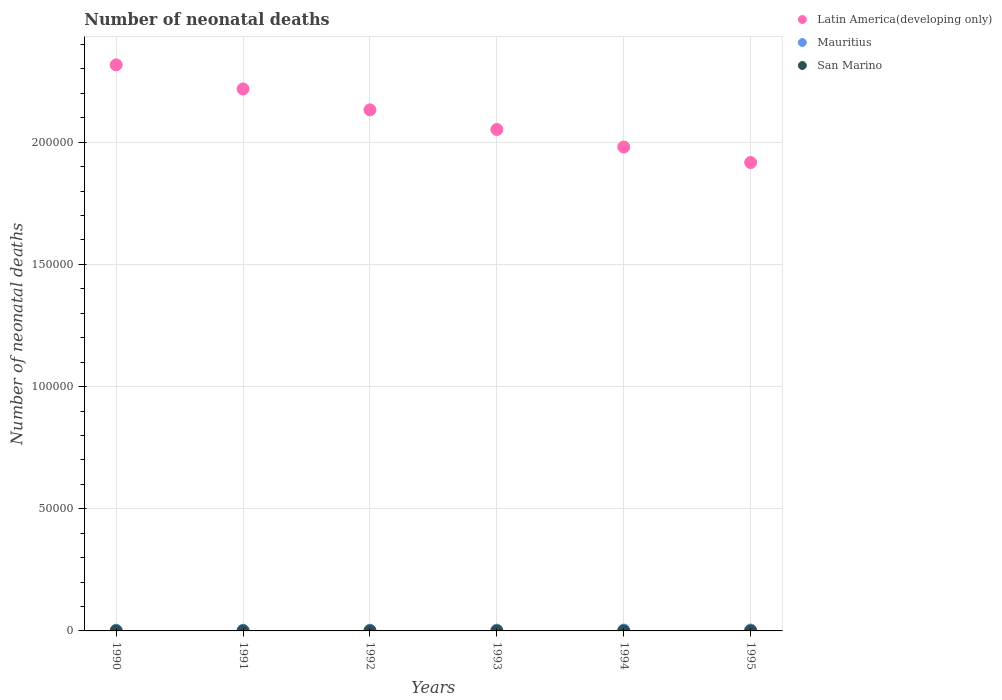How many different coloured dotlines are there?
Your answer should be compact. 3. Is the number of dotlines equal to the number of legend labels?
Keep it short and to the point. Yes. What is the number of neonatal deaths in in Mauritius in 1990?
Offer a terse response. 285. Across all years, what is the maximum number of neonatal deaths in in San Marino?
Your answer should be compact. 2. Across all years, what is the minimum number of neonatal deaths in in Latin America(developing only)?
Provide a succinct answer. 1.92e+05. In which year was the number of neonatal deaths in in Mauritius minimum?
Make the answer very short. 1990. What is the total number of neonatal deaths in in Latin America(developing only) in the graph?
Your answer should be very brief. 1.26e+06. What is the difference between the number of neonatal deaths in in Mauritius in 1990 and that in 1992?
Ensure brevity in your answer.  -22. What is the difference between the number of neonatal deaths in in Mauritius in 1991 and the number of neonatal deaths in in San Marino in 1990?
Your answer should be very brief. 287. What is the average number of neonatal deaths in in Latin America(developing only) per year?
Make the answer very short. 2.10e+05. In the year 1990, what is the difference between the number of neonatal deaths in in Mauritius and number of neonatal deaths in in Latin America(developing only)?
Offer a terse response. -2.31e+05. Is the difference between the number of neonatal deaths in in Mauritius in 1992 and 1993 greater than the difference between the number of neonatal deaths in in Latin America(developing only) in 1992 and 1993?
Your answer should be compact. No. What is the difference between the highest and the second highest number of neonatal deaths in in Latin America(developing only)?
Ensure brevity in your answer.  9854. What is the difference between the highest and the lowest number of neonatal deaths in in Latin America(developing only)?
Provide a short and direct response. 4.00e+04. In how many years, is the number of neonatal deaths in in Mauritius greater than the average number of neonatal deaths in in Mauritius taken over all years?
Provide a succinct answer. 3. Is the sum of the number of neonatal deaths in in San Marino in 1992 and 1993 greater than the maximum number of neonatal deaths in in Latin America(developing only) across all years?
Ensure brevity in your answer.  No. Is it the case that in every year, the sum of the number of neonatal deaths in in Mauritius and number of neonatal deaths in in Latin America(developing only)  is greater than the number of neonatal deaths in in San Marino?
Provide a succinct answer. Yes. Does the number of neonatal deaths in in Latin America(developing only) monotonically increase over the years?
Ensure brevity in your answer.  No. Is the number of neonatal deaths in in Latin America(developing only) strictly greater than the number of neonatal deaths in in Mauritius over the years?
Your response must be concise. Yes. Is the number of neonatal deaths in in Mauritius strictly less than the number of neonatal deaths in in Latin America(developing only) over the years?
Provide a succinct answer. Yes. Are the values on the major ticks of Y-axis written in scientific E-notation?
Provide a succinct answer. No. Does the graph contain grids?
Your answer should be very brief. Yes. Where does the legend appear in the graph?
Provide a succinct answer. Top right. How are the legend labels stacked?
Give a very brief answer. Vertical. What is the title of the graph?
Your answer should be compact. Number of neonatal deaths. What is the label or title of the Y-axis?
Your answer should be compact. Number of neonatal deaths. What is the Number of neonatal deaths in Latin America(developing only) in 1990?
Your answer should be compact. 2.32e+05. What is the Number of neonatal deaths in Mauritius in 1990?
Provide a succinct answer. 285. What is the Number of neonatal deaths in San Marino in 1990?
Your answer should be very brief. 2. What is the Number of neonatal deaths in Latin America(developing only) in 1991?
Your answer should be compact. 2.22e+05. What is the Number of neonatal deaths in Mauritius in 1991?
Give a very brief answer. 289. What is the Number of neonatal deaths of Latin America(developing only) in 1992?
Offer a terse response. 2.13e+05. What is the Number of neonatal deaths in Mauritius in 1992?
Provide a succinct answer. 307. What is the Number of neonatal deaths of Latin America(developing only) in 1993?
Give a very brief answer. 2.05e+05. What is the Number of neonatal deaths in Mauritius in 1993?
Give a very brief answer. 333. What is the Number of neonatal deaths of San Marino in 1993?
Give a very brief answer. 1. What is the Number of neonatal deaths of Latin America(developing only) in 1994?
Keep it short and to the point. 1.98e+05. What is the Number of neonatal deaths of Mauritius in 1994?
Make the answer very short. 359. What is the Number of neonatal deaths of Latin America(developing only) in 1995?
Provide a succinct answer. 1.92e+05. What is the Number of neonatal deaths in Mauritius in 1995?
Provide a succinct answer. 378. What is the Number of neonatal deaths in San Marino in 1995?
Provide a short and direct response. 1. Across all years, what is the maximum Number of neonatal deaths in Latin America(developing only)?
Give a very brief answer. 2.32e+05. Across all years, what is the maximum Number of neonatal deaths of Mauritius?
Keep it short and to the point. 378. Across all years, what is the maximum Number of neonatal deaths in San Marino?
Offer a very short reply. 2. Across all years, what is the minimum Number of neonatal deaths of Latin America(developing only)?
Offer a terse response. 1.92e+05. Across all years, what is the minimum Number of neonatal deaths in Mauritius?
Provide a short and direct response. 285. What is the total Number of neonatal deaths of Latin America(developing only) in the graph?
Provide a short and direct response. 1.26e+06. What is the total Number of neonatal deaths in Mauritius in the graph?
Ensure brevity in your answer.  1951. What is the difference between the Number of neonatal deaths of Latin America(developing only) in 1990 and that in 1991?
Your answer should be compact. 9854. What is the difference between the Number of neonatal deaths of San Marino in 1990 and that in 1991?
Offer a very short reply. 0. What is the difference between the Number of neonatal deaths of Latin America(developing only) in 1990 and that in 1992?
Ensure brevity in your answer.  1.84e+04. What is the difference between the Number of neonatal deaths in Latin America(developing only) in 1990 and that in 1993?
Make the answer very short. 2.64e+04. What is the difference between the Number of neonatal deaths of Mauritius in 1990 and that in 1993?
Your answer should be compact. -48. What is the difference between the Number of neonatal deaths of Latin America(developing only) in 1990 and that in 1994?
Offer a very short reply. 3.36e+04. What is the difference between the Number of neonatal deaths of Mauritius in 1990 and that in 1994?
Make the answer very short. -74. What is the difference between the Number of neonatal deaths in San Marino in 1990 and that in 1994?
Provide a succinct answer. 1. What is the difference between the Number of neonatal deaths in Latin America(developing only) in 1990 and that in 1995?
Your answer should be compact. 4.00e+04. What is the difference between the Number of neonatal deaths in Mauritius in 1990 and that in 1995?
Offer a terse response. -93. What is the difference between the Number of neonatal deaths of San Marino in 1990 and that in 1995?
Ensure brevity in your answer.  1. What is the difference between the Number of neonatal deaths in Latin America(developing only) in 1991 and that in 1992?
Make the answer very short. 8559. What is the difference between the Number of neonatal deaths of San Marino in 1991 and that in 1992?
Your response must be concise. 0. What is the difference between the Number of neonatal deaths of Latin America(developing only) in 1991 and that in 1993?
Your response must be concise. 1.66e+04. What is the difference between the Number of neonatal deaths in Mauritius in 1991 and that in 1993?
Offer a very short reply. -44. What is the difference between the Number of neonatal deaths in Latin America(developing only) in 1991 and that in 1994?
Your response must be concise. 2.38e+04. What is the difference between the Number of neonatal deaths in Mauritius in 1991 and that in 1994?
Make the answer very short. -70. What is the difference between the Number of neonatal deaths of Latin America(developing only) in 1991 and that in 1995?
Your answer should be very brief. 3.01e+04. What is the difference between the Number of neonatal deaths in Mauritius in 1991 and that in 1995?
Your response must be concise. -89. What is the difference between the Number of neonatal deaths in San Marino in 1991 and that in 1995?
Your answer should be compact. 1. What is the difference between the Number of neonatal deaths of Latin America(developing only) in 1992 and that in 1993?
Your answer should be compact. 8032. What is the difference between the Number of neonatal deaths in Latin America(developing only) in 1992 and that in 1994?
Offer a very short reply. 1.52e+04. What is the difference between the Number of neonatal deaths in Mauritius in 1992 and that in 1994?
Keep it short and to the point. -52. What is the difference between the Number of neonatal deaths of Latin America(developing only) in 1992 and that in 1995?
Your response must be concise. 2.16e+04. What is the difference between the Number of neonatal deaths in Mauritius in 1992 and that in 1995?
Provide a short and direct response. -71. What is the difference between the Number of neonatal deaths of Latin America(developing only) in 1993 and that in 1994?
Offer a very short reply. 7178. What is the difference between the Number of neonatal deaths of Latin America(developing only) in 1993 and that in 1995?
Provide a short and direct response. 1.35e+04. What is the difference between the Number of neonatal deaths of Mauritius in 1993 and that in 1995?
Your answer should be very brief. -45. What is the difference between the Number of neonatal deaths in San Marino in 1993 and that in 1995?
Give a very brief answer. 0. What is the difference between the Number of neonatal deaths in Latin America(developing only) in 1994 and that in 1995?
Keep it short and to the point. 6341. What is the difference between the Number of neonatal deaths in Mauritius in 1994 and that in 1995?
Your answer should be very brief. -19. What is the difference between the Number of neonatal deaths in Latin America(developing only) in 1990 and the Number of neonatal deaths in Mauritius in 1991?
Your answer should be compact. 2.31e+05. What is the difference between the Number of neonatal deaths of Latin America(developing only) in 1990 and the Number of neonatal deaths of San Marino in 1991?
Make the answer very short. 2.32e+05. What is the difference between the Number of neonatal deaths in Mauritius in 1990 and the Number of neonatal deaths in San Marino in 1991?
Keep it short and to the point. 283. What is the difference between the Number of neonatal deaths in Latin America(developing only) in 1990 and the Number of neonatal deaths in Mauritius in 1992?
Offer a terse response. 2.31e+05. What is the difference between the Number of neonatal deaths in Latin America(developing only) in 1990 and the Number of neonatal deaths in San Marino in 1992?
Offer a terse response. 2.32e+05. What is the difference between the Number of neonatal deaths of Mauritius in 1990 and the Number of neonatal deaths of San Marino in 1992?
Provide a succinct answer. 283. What is the difference between the Number of neonatal deaths in Latin America(developing only) in 1990 and the Number of neonatal deaths in Mauritius in 1993?
Your response must be concise. 2.31e+05. What is the difference between the Number of neonatal deaths in Latin America(developing only) in 1990 and the Number of neonatal deaths in San Marino in 1993?
Offer a terse response. 2.32e+05. What is the difference between the Number of neonatal deaths in Mauritius in 1990 and the Number of neonatal deaths in San Marino in 1993?
Ensure brevity in your answer.  284. What is the difference between the Number of neonatal deaths in Latin America(developing only) in 1990 and the Number of neonatal deaths in Mauritius in 1994?
Make the answer very short. 2.31e+05. What is the difference between the Number of neonatal deaths of Latin America(developing only) in 1990 and the Number of neonatal deaths of San Marino in 1994?
Offer a terse response. 2.32e+05. What is the difference between the Number of neonatal deaths of Mauritius in 1990 and the Number of neonatal deaths of San Marino in 1994?
Ensure brevity in your answer.  284. What is the difference between the Number of neonatal deaths of Latin America(developing only) in 1990 and the Number of neonatal deaths of Mauritius in 1995?
Keep it short and to the point. 2.31e+05. What is the difference between the Number of neonatal deaths of Latin America(developing only) in 1990 and the Number of neonatal deaths of San Marino in 1995?
Provide a succinct answer. 2.32e+05. What is the difference between the Number of neonatal deaths of Mauritius in 1990 and the Number of neonatal deaths of San Marino in 1995?
Your answer should be very brief. 284. What is the difference between the Number of neonatal deaths of Latin America(developing only) in 1991 and the Number of neonatal deaths of Mauritius in 1992?
Offer a terse response. 2.22e+05. What is the difference between the Number of neonatal deaths in Latin America(developing only) in 1991 and the Number of neonatal deaths in San Marino in 1992?
Your answer should be compact. 2.22e+05. What is the difference between the Number of neonatal deaths in Mauritius in 1991 and the Number of neonatal deaths in San Marino in 1992?
Offer a terse response. 287. What is the difference between the Number of neonatal deaths in Latin America(developing only) in 1991 and the Number of neonatal deaths in Mauritius in 1993?
Your answer should be very brief. 2.21e+05. What is the difference between the Number of neonatal deaths in Latin America(developing only) in 1991 and the Number of neonatal deaths in San Marino in 1993?
Your answer should be compact. 2.22e+05. What is the difference between the Number of neonatal deaths of Mauritius in 1991 and the Number of neonatal deaths of San Marino in 1993?
Your answer should be very brief. 288. What is the difference between the Number of neonatal deaths in Latin America(developing only) in 1991 and the Number of neonatal deaths in Mauritius in 1994?
Provide a short and direct response. 2.21e+05. What is the difference between the Number of neonatal deaths in Latin America(developing only) in 1991 and the Number of neonatal deaths in San Marino in 1994?
Ensure brevity in your answer.  2.22e+05. What is the difference between the Number of neonatal deaths in Mauritius in 1991 and the Number of neonatal deaths in San Marino in 1994?
Keep it short and to the point. 288. What is the difference between the Number of neonatal deaths in Latin America(developing only) in 1991 and the Number of neonatal deaths in Mauritius in 1995?
Ensure brevity in your answer.  2.21e+05. What is the difference between the Number of neonatal deaths of Latin America(developing only) in 1991 and the Number of neonatal deaths of San Marino in 1995?
Offer a terse response. 2.22e+05. What is the difference between the Number of neonatal deaths of Mauritius in 1991 and the Number of neonatal deaths of San Marino in 1995?
Offer a very short reply. 288. What is the difference between the Number of neonatal deaths in Latin America(developing only) in 1992 and the Number of neonatal deaths in Mauritius in 1993?
Provide a succinct answer. 2.13e+05. What is the difference between the Number of neonatal deaths of Latin America(developing only) in 1992 and the Number of neonatal deaths of San Marino in 1993?
Your answer should be very brief. 2.13e+05. What is the difference between the Number of neonatal deaths in Mauritius in 1992 and the Number of neonatal deaths in San Marino in 1993?
Provide a short and direct response. 306. What is the difference between the Number of neonatal deaths in Latin America(developing only) in 1992 and the Number of neonatal deaths in Mauritius in 1994?
Provide a short and direct response. 2.13e+05. What is the difference between the Number of neonatal deaths of Latin America(developing only) in 1992 and the Number of neonatal deaths of San Marino in 1994?
Your answer should be very brief. 2.13e+05. What is the difference between the Number of neonatal deaths of Mauritius in 1992 and the Number of neonatal deaths of San Marino in 1994?
Ensure brevity in your answer.  306. What is the difference between the Number of neonatal deaths of Latin America(developing only) in 1992 and the Number of neonatal deaths of Mauritius in 1995?
Provide a short and direct response. 2.13e+05. What is the difference between the Number of neonatal deaths of Latin America(developing only) in 1992 and the Number of neonatal deaths of San Marino in 1995?
Ensure brevity in your answer.  2.13e+05. What is the difference between the Number of neonatal deaths of Mauritius in 1992 and the Number of neonatal deaths of San Marino in 1995?
Provide a succinct answer. 306. What is the difference between the Number of neonatal deaths of Latin America(developing only) in 1993 and the Number of neonatal deaths of Mauritius in 1994?
Your response must be concise. 2.05e+05. What is the difference between the Number of neonatal deaths of Latin America(developing only) in 1993 and the Number of neonatal deaths of San Marino in 1994?
Make the answer very short. 2.05e+05. What is the difference between the Number of neonatal deaths in Mauritius in 1993 and the Number of neonatal deaths in San Marino in 1994?
Keep it short and to the point. 332. What is the difference between the Number of neonatal deaths of Latin America(developing only) in 1993 and the Number of neonatal deaths of Mauritius in 1995?
Offer a very short reply. 2.05e+05. What is the difference between the Number of neonatal deaths in Latin America(developing only) in 1993 and the Number of neonatal deaths in San Marino in 1995?
Your response must be concise. 2.05e+05. What is the difference between the Number of neonatal deaths in Mauritius in 1993 and the Number of neonatal deaths in San Marino in 1995?
Make the answer very short. 332. What is the difference between the Number of neonatal deaths of Latin America(developing only) in 1994 and the Number of neonatal deaths of Mauritius in 1995?
Offer a very short reply. 1.98e+05. What is the difference between the Number of neonatal deaths of Latin America(developing only) in 1994 and the Number of neonatal deaths of San Marino in 1995?
Provide a succinct answer. 1.98e+05. What is the difference between the Number of neonatal deaths in Mauritius in 1994 and the Number of neonatal deaths in San Marino in 1995?
Your answer should be very brief. 358. What is the average Number of neonatal deaths of Latin America(developing only) per year?
Ensure brevity in your answer.  2.10e+05. What is the average Number of neonatal deaths of Mauritius per year?
Your answer should be very brief. 325.17. What is the average Number of neonatal deaths of San Marino per year?
Give a very brief answer. 1.5. In the year 1990, what is the difference between the Number of neonatal deaths in Latin America(developing only) and Number of neonatal deaths in Mauritius?
Provide a succinct answer. 2.31e+05. In the year 1990, what is the difference between the Number of neonatal deaths in Latin America(developing only) and Number of neonatal deaths in San Marino?
Offer a terse response. 2.32e+05. In the year 1990, what is the difference between the Number of neonatal deaths of Mauritius and Number of neonatal deaths of San Marino?
Ensure brevity in your answer.  283. In the year 1991, what is the difference between the Number of neonatal deaths of Latin America(developing only) and Number of neonatal deaths of Mauritius?
Keep it short and to the point. 2.22e+05. In the year 1991, what is the difference between the Number of neonatal deaths of Latin America(developing only) and Number of neonatal deaths of San Marino?
Give a very brief answer. 2.22e+05. In the year 1991, what is the difference between the Number of neonatal deaths of Mauritius and Number of neonatal deaths of San Marino?
Provide a succinct answer. 287. In the year 1992, what is the difference between the Number of neonatal deaths in Latin America(developing only) and Number of neonatal deaths in Mauritius?
Your response must be concise. 2.13e+05. In the year 1992, what is the difference between the Number of neonatal deaths in Latin America(developing only) and Number of neonatal deaths in San Marino?
Your answer should be compact. 2.13e+05. In the year 1992, what is the difference between the Number of neonatal deaths of Mauritius and Number of neonatal deaths of San Marino?
Your answer should be very brief. 305. In the year 1993, what is the difference between the Number of neonatal deaths of Latin America(developing only) and Number of neonatal deaths of Mauritius?
Make the answer very short. 2.05e+05. In the year 1993, what is the difference between the Number of neonatal deaths in Latin America(developing only) and Number of neonatal deaths in San Marino?
Your answer should be compact. 2.05e+05. In the year 1993, what is the difference between the Number of neonatal deaths in Mauritius and Number of neonatal deaths in San Marino?
Make the answer very short. 332. In the year 1994, what is the difference between the Number of neonatal deaths of Latin America(developing only) and Number of neonatal deaths of Mauritius?
Provide a succinct answer. 1.98e+05. In the year 1994, what is the difference between the Number of neonatal deaths of Latin America(developing only) and Number of neonatal deaths of San Marino?
Make the answer very short. 1.98e+05. In the year 1994, what is the difference between the Number of neonatal deaths in Mauritius and Number of neonatal deaths in San Marino?
Offer a terse response. 358. In the year 1995, what is the difference between the Number of neonatal deaths of Latin America(developing only) and Number of neonatal deaths of Mauritius?
Make the answer very short. 1.91e+05. In the year 1995, what is the difference between the Number of neonatal deaths of Latin America(developing only) and Number of neonatal deaths of San Marino?
Keep it short and to the point. 1.92e+05. In the year 1995, what is the difference between the Number of neonatal deaths of Mauritius and Number of neonatal deaths of San Marino?
Ensure brevity in your answer.  377. What is the ratio of the Number of neonatal deaths of Latin America(developing only) in 1990 to that in 1991?
Give a very brief answer. 1.04. What is the ratio of the Number of neonatal deaths in Mauritius in 1990 to that in 1991?
Offer a terse response. 0.99. What is the ratio of the Number of neonatal deaths of Latin America(developing only) in 1990 to that in 1992?
Provide a succinct answer. 1.09. What is the ratio of the Number of neonatal deaths in Mauritius in 1990 to that in 1992?
Ensure brevity in your answer.  0.93. What is the ratio of the Number of neonatal deaths in Latin America(developing only) in 1990 to that in 1993?
Give a very brief answer. 1.13. What is the ratio of the Number of neonatal deaths in Mauritius in 1990 to that in 1993?
Provide a short and direct response. 0.86. What is the ratio of the Number of neonatal deaths in Latin America(developing only) in 1990 to that in 1994?
Keep it short and to the point. 1.17. What is the ratio of the Number of neonatal deaths in Mauritius in 1990 to that in 1994?
Make the answer very short. 0.79. What is the ratio of the Number of neonatal deaths of Latin America(developing only) in 1990 to that in 1995?
Keep it short and to the point. 1.21. What is the ratio of the Number of neonatal deaths of Mauritius in 1990 to that in 1995?
Offer a terse response. 0.75. What is the ratio of the Number of neonatal deaths of San Marino in 1990 to that in 1995?
Keep it short and to the point. 2. What is the ratio of the Number of neonatal deaths of Latin America(developing only) in 1991 to that in 1992?
Offer a terse response. 1.04. What is the ratio of the Number of neonatal deaths of Mauritius in 1991 to that in 1992?
Provide a succinct answer. 0.94. What is the ratio of the Number of neonatal deaths in Latin America(developing only) in 1991 to that in 1993?
Offer a terse response. 1.08. What is the ratio of the Number of neonatal deaths of Mauritius in 1991 to that in 1993?
Offer a very short reply. 0.87. What is the ratio of the Number of neonatal deaths of San Marino in 1991 to that in 1993?
Keep it short and to the point. 2. What is the ratio of the Number of neonatal deaths of Latin America(developing only) in 1991 to that in 1994?
Your response must be concise. 1.12. What is the ratio of the Number of neonatal deaths in Mauritius in 1991 to that in 1994?
Keep it short and to the point. 0.81. What is the ratio of the Number of neonatal deaths in San Marino in 1991 to that in 1994?
Make the answer very short. 2. What is the ratio of the Number of neonatal deaths of Latin America(developing only) in 1991 to that in 1995?
Give a very brief answer. 1.16. What is the ratio of the Number of neonatal deaths of Mauritius in 1991 to that in 1995?
Provide a short and direct response. 0.76. What is the ratio of the Number of neonatal deaths of San Marino in 1991 to that in 1995?
Keep it short and to the point. 2. What is the ratio of the Number of neonatal deaths of Latin America(developing only) in 1992 to that in 1993?
Provide a succinct answer. 1.04. What is the ratio of the Number of neonatal deaths of Mauritius in 1992 to that in 1993?
Offer a very short reply. 0.92. What is the ratio of the Number of neonatal deaths of San Marino in 1992 to that in 1993?
Your answer should be very brief. 2. What is the ratio of the Number of neonatal deaths in Latin America(developing only) in 1992 to that in 1994?
Make the answer very short. 1.08. What is the ratio of the Number of neonatal deaths of Mauritius in 1992 to that in 1994?
Give a very brief answer. 0.86. What is the ratio of the Number of neonatal deaths of San Marino in 1992 to that in 1994?
Your answer should be compact. 2. What is the ratio of the Number of neonatal deaths of Latin America(developing only) in 1992 to that in 1995?
Offer a terse response. 1.11. What is the ratio of the Number of neonatal deaths in Mauritius in 1992 to that in 1995?
Provide a succinct answer. 0.81. What is the ratio of the Number of neonatal deaths of San Marino in 1992 to that in 1995?
Keep it short and to the point. 2. What is the ratio of the Number of neonatal deaths of Latin America(developing only) in 1993 to that in 1994?
Your answer should be compact. 1.04. What is the ratio of the Number of neonatal deaths of Mauritius in 1993 to that in 1994?
Make the answer very short. 0.93. What is the ratio of the Number of neonatal deaths of Latin America(developing only) in 1993 to that in 1995?
Offer a very short reply. 1.07. What is the ratio of the Number of neonatal deaths of Mauritius in 1993 to that in 1995?
Give a very brief answer. 0.88. What is the ratio of the Number of neonatal deaths in San Marino in 1993 to that in 1995?
Provide a succinct answer. 1. What is the ratio of the Number of neonatal deaths in Latin America(developing only) in 1994 to that in 1995?
Your answer should be very brief. 1.03. What is the ratio of the Number of neonatal deaths of Mauritius in 1994 to that in 1995?
Give a very brief answer. 0.95. What is the ratio of the Number of neonatal deaths of San Marino in 1994 to that in 1995?
Keep it short and to the point. 1. What is the difference between the highest and the second highest Number of neonatal deaths in Latin America(developing only)?
Ensure brevity in your answer.  9854. What is the difference between the highest and the lowest Number of neonatal deaths in Latin America(developing only)?
Provide a succinct answer. 4.00e+04. What is the difference between the highest and the lowest Number of neonatal deaths of Mauritius?
Provide a succinct answer. 93. 